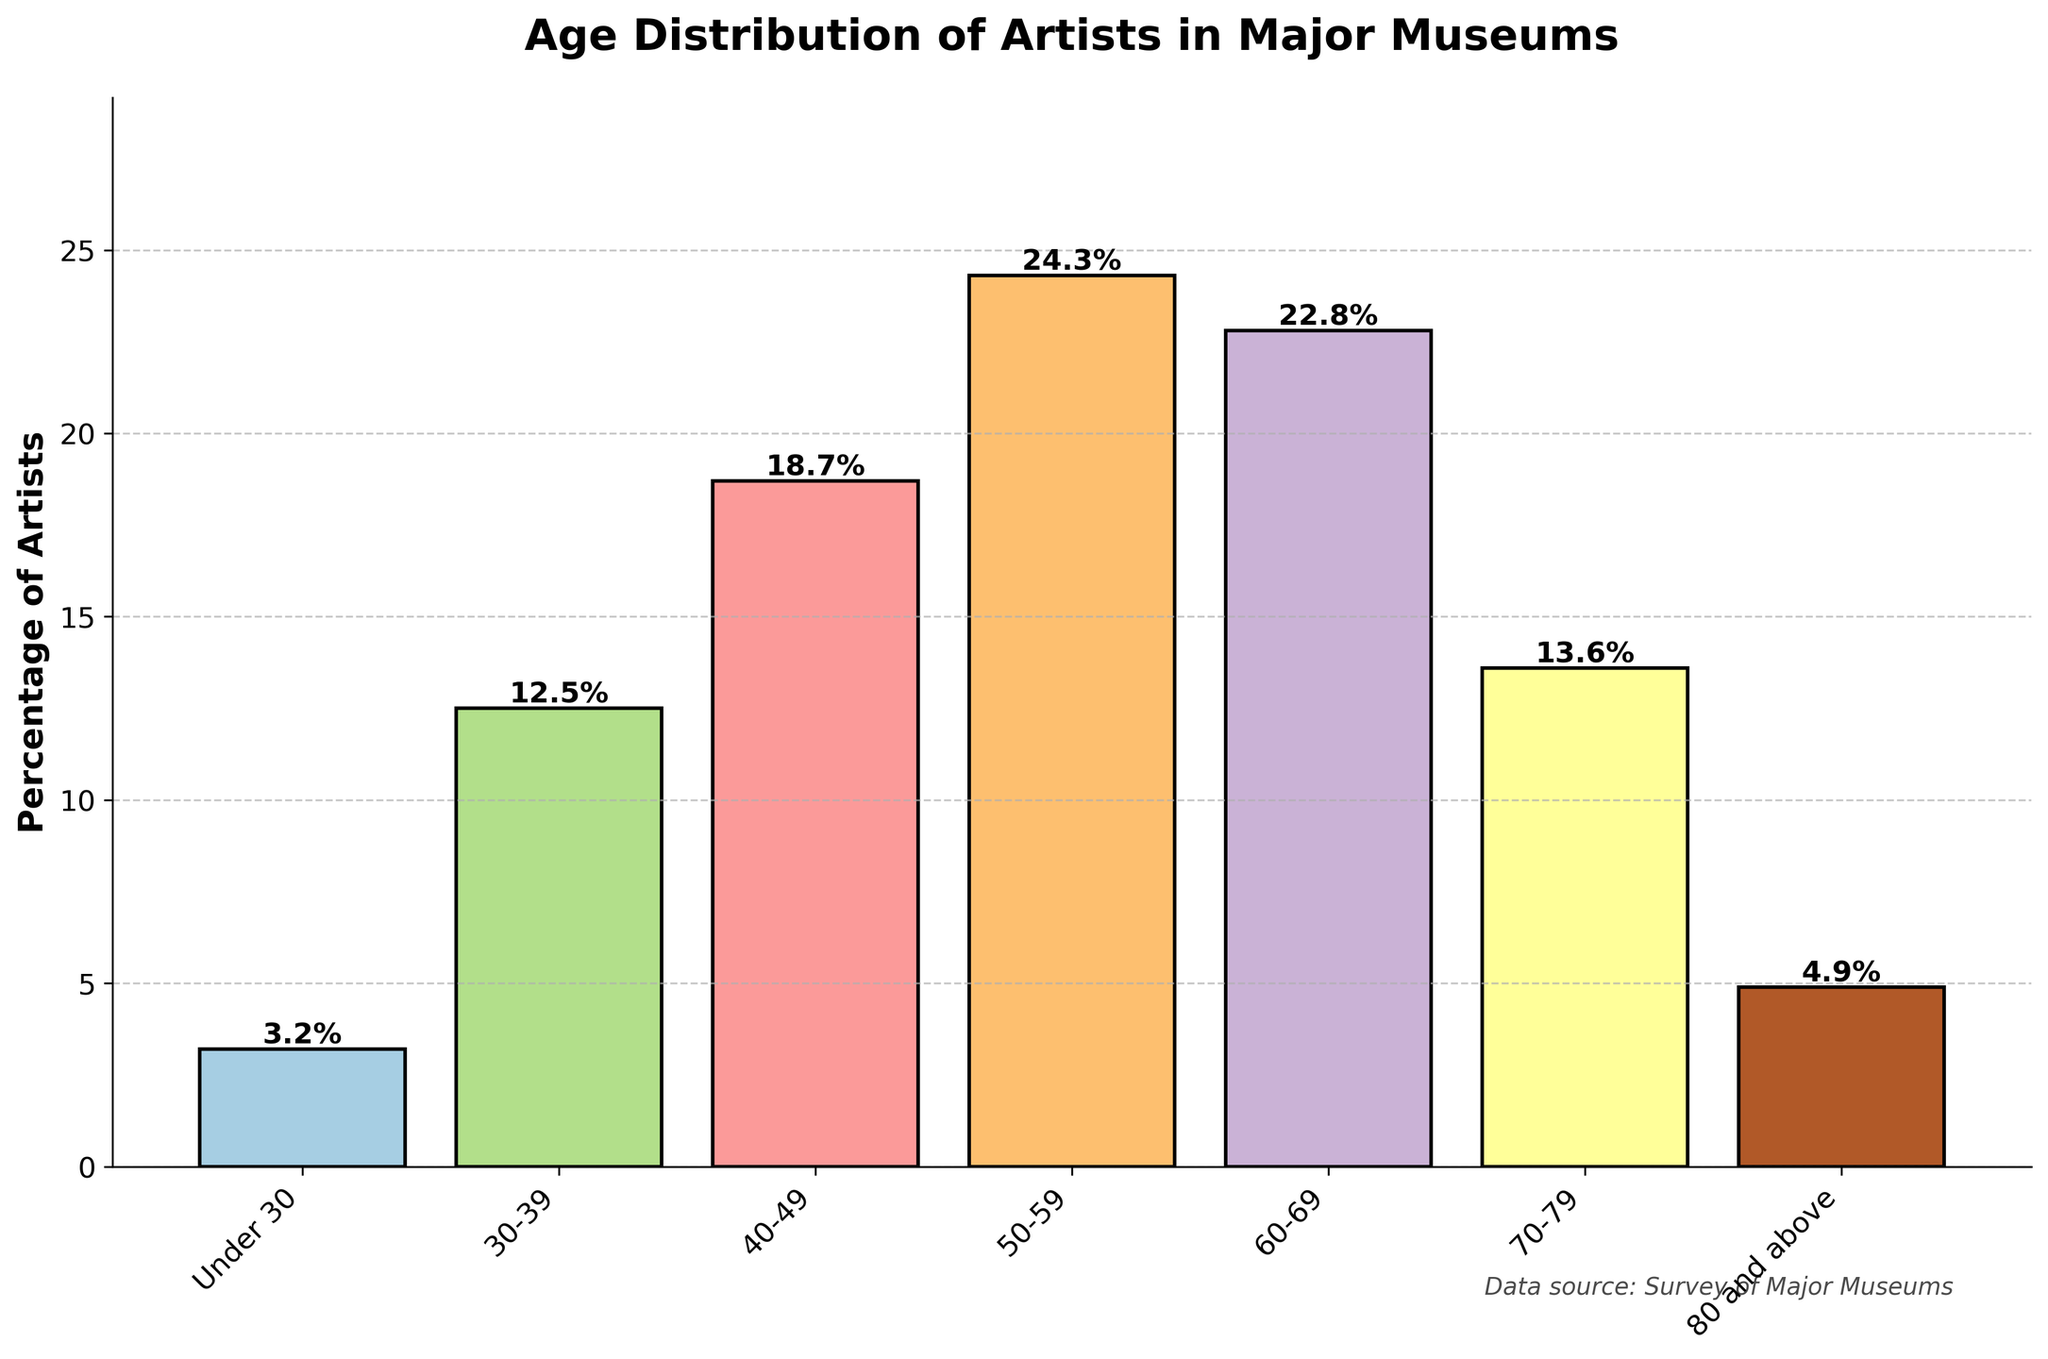what's the most represented age range in the chart? The chart indicates the percentage of artists by age range, with the 50-59 age range having the highest percentage at 24.3%. This is evident as the bar for 50-59 is the tallest in the chart.
Answer: 50-59 which age range has the least representation in major museums? By examining the chart, we see that the "Under 30" age range has the smallest percentage at 3.2%, indicated by the shortest bar.
Answer: Under 30 how does the percentage of artists aged 30-39 compare with those aged 60-69? The bar for the 60-69 age range is at 22.8% while the bar for the 30-39 age range is at 12.5%. Comparing these, the percentage of artists aged 60-69 is higher by 10.3%.
Answer: 22.8% > 12.5% what is the combined percentage of artists aged 40-49 and 50-59? Adding the percentages of the 40-49 and 50-59 age ranges, we get 18.7% + 24.3%, totaling 43%.
Answer: 43% are there more artists aged 70-79 or those aged 80 and above? The chart shows that the percentage of artists aged 70-79 is 13.6%, while those aged 80 and above is 4.9%. Therefore, there are more artists aged 70-79.
Answer: 70-79 what is the average percentage of artists for all age ranges? Summing all the percentages: 3.2% + 12.5% + 18.7% + 24.3% + 22.8% + 13.6% + 4.9% gives 100%. Since there are 7 age ranges, the average is 100% / 7 = 14.3%.
Answer: 14.3% what visual cues identify the highest and lowest percentages on the chart? The height of the bars is the primary visual cue. The tallest bar represents the 50-59 age range with the highest percentage, while the shortest bar represents the "Under 30" age range with the lowest percentage.
Answer: bar heights how much higher is the percentage of artists aged 50-59 compared to those under 30? The chart shows that the percentage of artists aged 50-59 is 24.3%, and the percentage for those under 30 is 3.2%. The difference is 24.3% - 3.2% = 21.1%.
Answer: 21.1% what is the range of artist percentages across all age groups? The highest percentage is 24.3% (50-59 age group) and the lowest is 3.2% (Under 30). The range is 24.3% - 3.2% = 21.1%.
Answer: 21.1% 